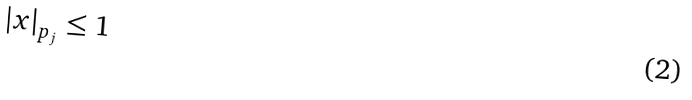<formula> <loc_0><loc_0><loc_500><loc_500>| x | _ { p _ { j } } \leq 1</formula> 